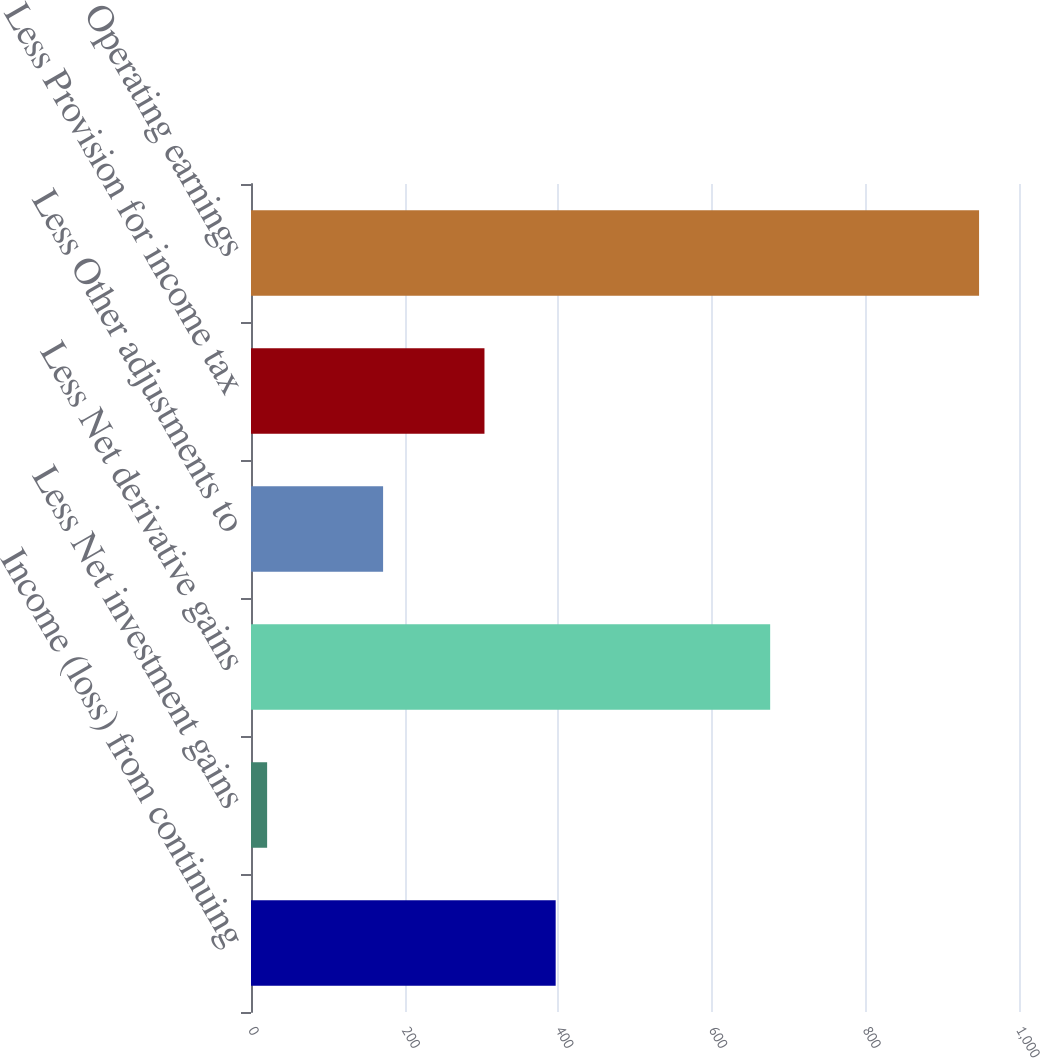<chart> <loc_0><loc_0><loc_500><loc_500><bar_chart><fcel>Income (loss) from continuing<fcel>Less Net investment gains<fcel>Less Net derivative gains<fcel>Less Other adjustments to<fcel>Less Provision for income tax<fcel>Operating earnings<nl><fcel>396.7<fcel>21<fcel>676<fcel>172<fcel>304<fcel>948<nl></chart> 